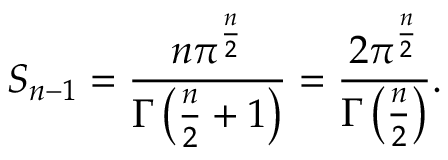Convert formula to latex. <formula><loc_0><loc_0><loc_500><loc_500>S _ { n - 1 } = { \frac { n \pi ^ { \frac { n } { 2 } } } { \Gamma \left ( { \frac { n } { 2 } } + 1 \right ) } } = { \frac { 2 \pi ^ { \frac { n } { 2 } } } { \Gamma \left ( { \frac { n } { 2 } } \right ) } } .</formula> 